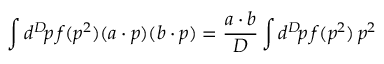<formula> <loc_0><loc_0><loc_500><loc_500>\int d ^ { D } \, p \, f ( p ^ { 2 } ) ( a \cdot p ) ( b \cdot p ) = { \frac { a \cdot b } { D } } \int d ^ { D } \, p \, f ( p ^ { 2 } ) \, p ^ { 2 }</formula> 